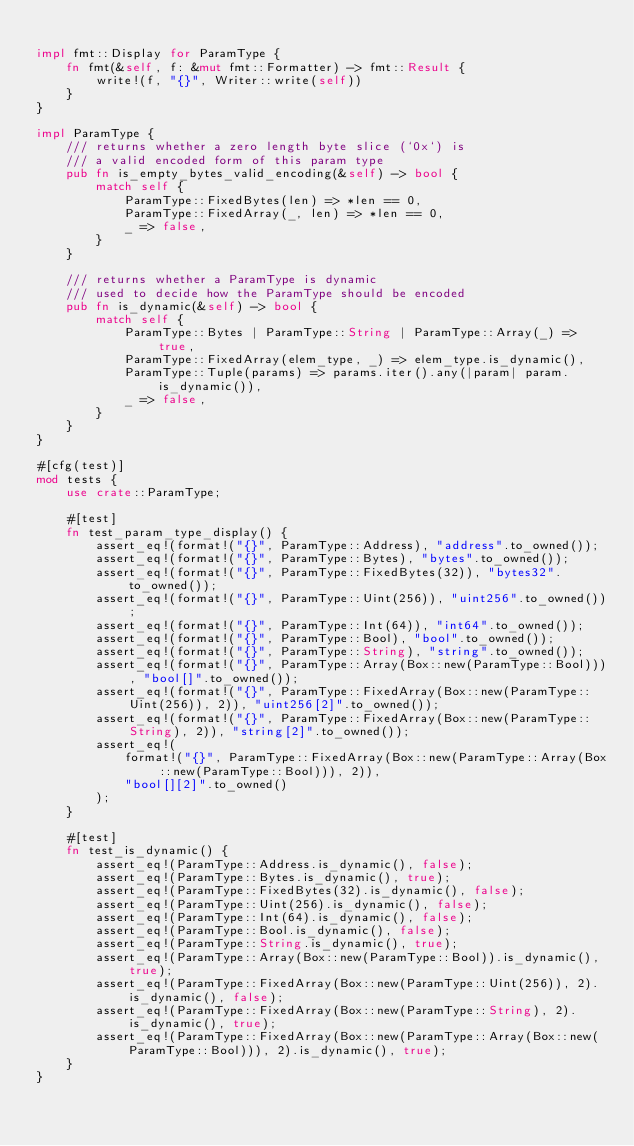Convert code to text. <code><loc_0><loc_0><loc_500><loc_500><_Rust_>
impl fmt::Display for ParamType {
	fn fmt(&self, f: &mut fmt::Formatter) -> fmt::Result {
		write!(f, "{}", Writer::write(self))
	}
}

impl ParamType {
	/// returns whether a zero length byte slice (`0x`) is
	/// a valid encoded form of this param type
	pub fn is_empty_bytes_valid_encoding(&self) -> bool {
		match self {
			ParamType::FixedBytes(len) => *len == 0,
			ParamType::FixedArray(_, len) => *len == 0,
			_ => false,
		}
	}

	/// returns whether a ParamType is dynamic
	/// used to decide how the ParamType should be encoded
	pub fn is_dynamic(&self) -> bool {
		match self {
			ParamType::Bytes | ParamType::String | ParamType::Array(_) => true,
			ParamType::FixedArray(elem_type, _) => elem_type.is_dynamic(),
			ParamType::Tuple(params) => params.iter().any(|param| param.is_dynamic()),
			_ => false,
		}
	}
}

#[cfg(test)]
mod tests {
	use crate::ParamType;

	#[test]
	fn test_param_type_display() {
		assert_eq!(format!("{}", ParamType::Address), "address".to_owned());
		assert_eq!(format!("{}", ParamType::Bytes), "bytes".to_owned());
		assert_eq!(format!("{}", ParamType::FixedBytes(32)), "bytes32".to_owned());
		assert_eq!(format!("{}", ParamType::Uint(256)), "uint256".to_owned());
		assert_eq!(format!("{}", ParamType::Int(64)), "int64".to_owned());
		assert_eq!(format!("{}", ParamType::Bool), "bool".to_owned());
		assert_eq!(format!("{}", ParamType::String), "string".to_owned());
		assert_eq!(format!("{}", ParamType::Array(Box::new(ParamType::Bool))), "bool[]".to_owned());
		assert_eq!(format!("{}", ParamType::FixedArray(Box::new(ParamType::Uint(256)), 2)), "uint256[2]".to_owned());
		assert_eq!(format!("{}", ParamType::FixedArray(Box::new(ParamType::String), 2)), "string[2]".to_owned());
		assert_eq!(
			format!("{}", ParamType::FixedArray(Box::new(ParamType::Array(Box::new(ParamType::Bool))), 2)),
			"bool[][2]".to_owned()
		);
	}

	#[test]
	fn test_is_dynamic() {
		assert_eq!(ParamType::Address.is_dynamic(), false);
		assert_eq!(ParamType::Bytes.is_dynamic(), true);
		assert_eq!(ParamType::FixedBytes(32).is_dynamic(), false);
		assert_eq!(ParamType::Uint(256).is_dynamic(), false);
		assert_eq!(ParamType::Int(64).is_dynamic(), false);
		assert_eq!(ParamType::Bool.is_dynamic(), false);
		assert_eq!(ParamType::String.is_dynamic(), true);
		assert_eq!(ParamType::Array(Box::new(ParamType::Bool)).is_dynamic(), true);
		assert_eq!(ParamType::FixedArray(Box::new(ParamType::Uint(256)), 2).is_dynamic(), false);
		assert_eq!(ParamType::FixedArray(Box::new(ParamType::String), 2).is_dynamic(), true);
		assert_eq!(ParamType::FixedArray(Box::new(ParamType::Array(Box::new(ParamType::Bool))), 2).is_dynamic(), true);
	}
}
</code> 